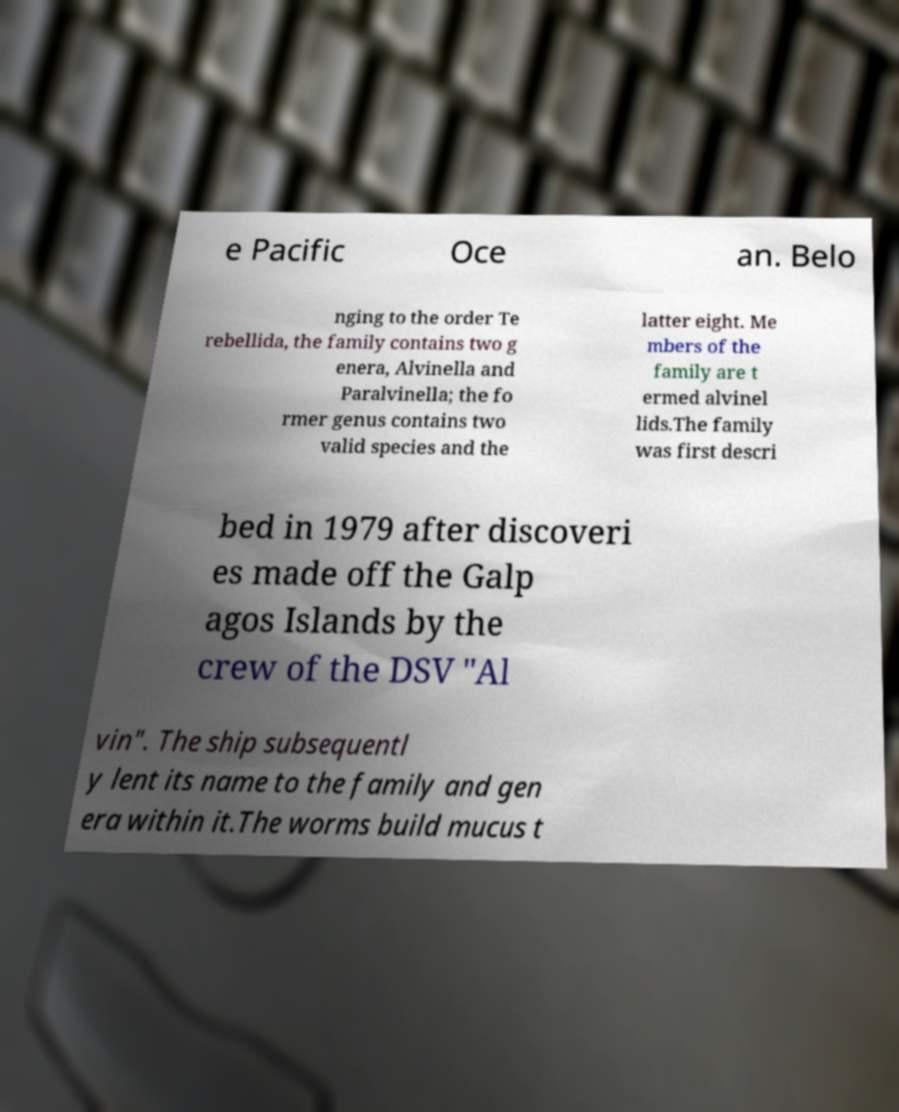Please identify and transcribe the text found in this image. e Pacific Oce an. Belo nging to the order Te rebellida, the family contains two g enera, Alvinella and Paralvinella; the fo rmer genus contains two valid species and the latter eight. Me mbers of the family are t ermed alvinel lids.The family was first descri bed in 1979 after discoveri es made off the Galp agos Islands by the crew of the DSV "Al vin". The ship subsequentl y lent its name to the family and gen era within it.The worms build mucus t 